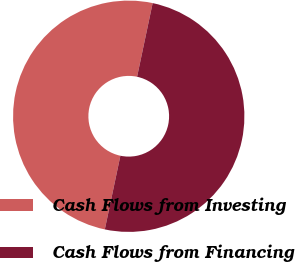Convert chart. <chart><loc_0><loc_0><loc_500><loc_500><pie_chart><fcel>Cash Flows from Investing<fcel>Cash Flows from Financing<nl><fcel>50.0%<fcel>50.0%<nl></chart> 